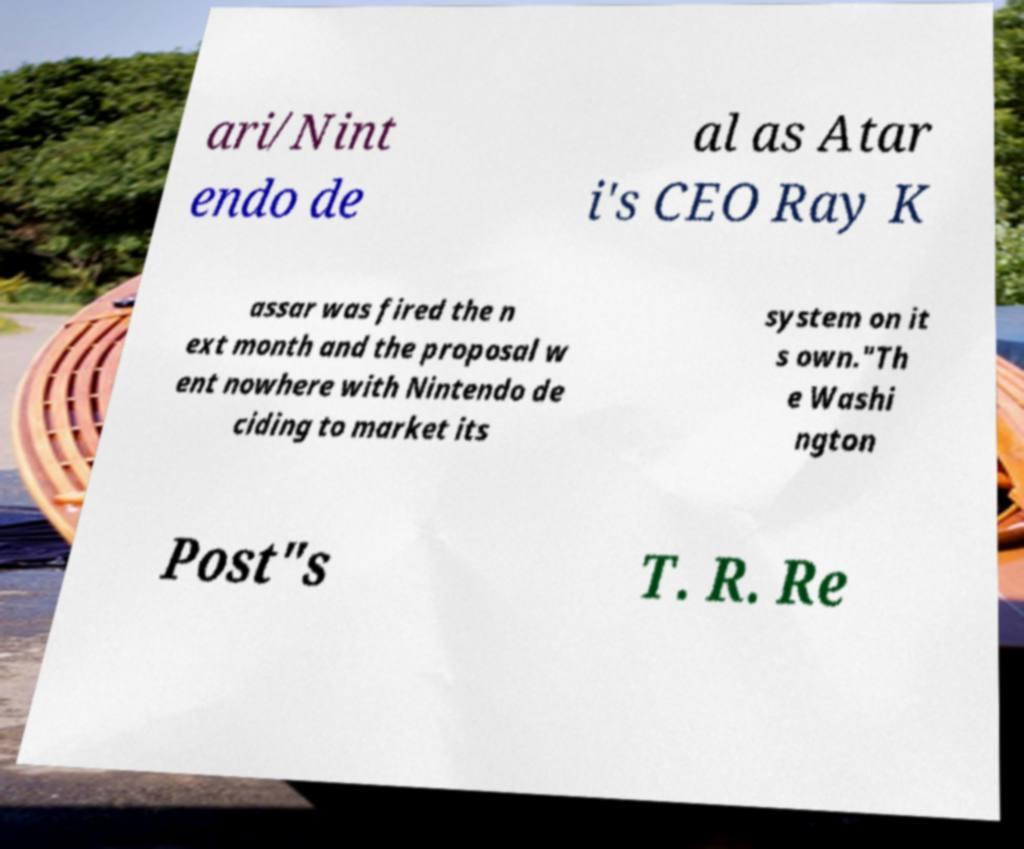There's text embedded in this image that I need extracted. Can you transcribe it verbatim? ari/Nint endo de al as Atar i's CEO Ray K assar was fired the n ext month and the proposal w ent nowhere with Nintendo de ciding to market its system on it s own."Th e Washi ngton Post"s T. R. Re 